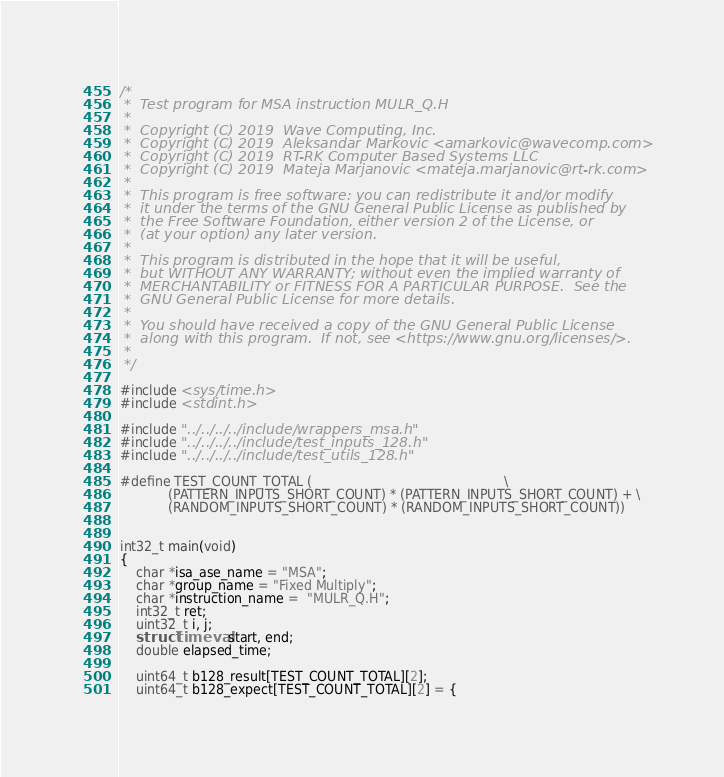Convert code to text. <code><loc_0><loc_0><loc_500><loc_500><_C_>/*
 *  Test program for MSA instruction MULR_Q.H
 *
 *  Copyright (C) 2019  Wave Computing, Inc.
 *  Copyright (C) 2019  Aleksandar Markovic <amarkovic@wavecomp.com>
 *  Copyright (C) 2019  RT-RK Computer Based Systems LLC
 *  Copyright (C) 2019  Mateja Marjanovic <mateja.marjanovic@rt-rk.com>
 *
 *  This program is free software: you can redistribute it and/or modify
 *  it under the terms of the GNU General Public License as published by
 *  the Free Software Foundation, either version 2 of the License, or
 *  (at your option) any later version.
 *
 *  This program is distributed in the hope that it will be useful,
 *  but WITHOUT ANY WARRANTY; without even the implied warranty of
 *  MERCHANTABILITY or FITNESS FOR A PARTICULAR PURPOSE.  See the
 *  GNU General Public License for more details.
 *
 *  You should have received a copy of the GNU General Public License
 *  along with this program.  If not, see <https://www.gnu.org/licenses/>.
 *
 */

#include <sys/time.h>
#include <stdint.h>

#include "../../../../include/wrappers_msa.h"
#include "../../../../include/test_inputs_128.h"
#include "../../../../include/test_utils_128.h"

#define TEST_COUNT_TOTAL (                                                \
            (PATTERN_INPUTS_SHORT_COUNT) * (PATTERN_INPUTS_SHORT_COUNT) + \
            (RANDOM_INPUTS_SHORT_COUNT) * (RANDOM_INPUTS_SHORT_COUNT))


int32_t main(void)
{
    char *isa_ase_name = "MSA";
    char *group_name = "Fixed Multiply";
    char *instruction_name =  "MULR_Q.H";
    int32_t ret;
    uint32_t i, j;
    struct timeval start, end;
    double elapsed_time;

    uint64_t b128_result[TEST_COUNT_TOTAL][2];
    uint64_t b128_expect[TEST_COUNT_TOTAL][2] = {</code> 